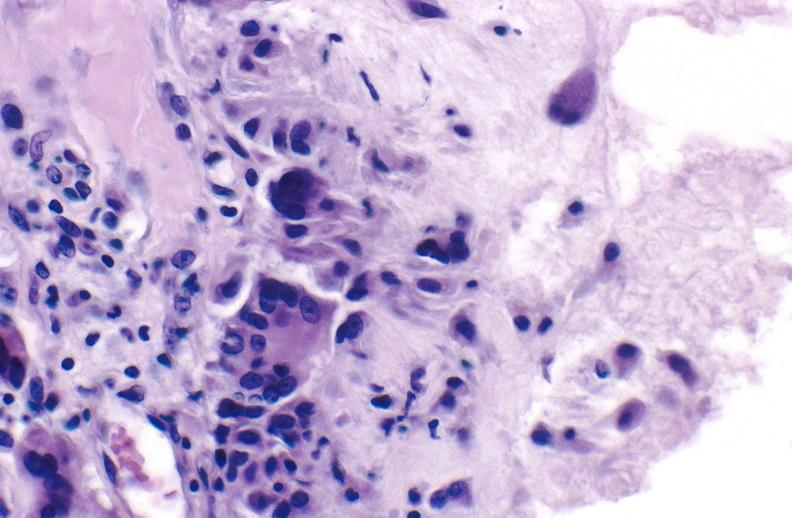s joints present?
Answer the question using a single word or phrase. Yes 